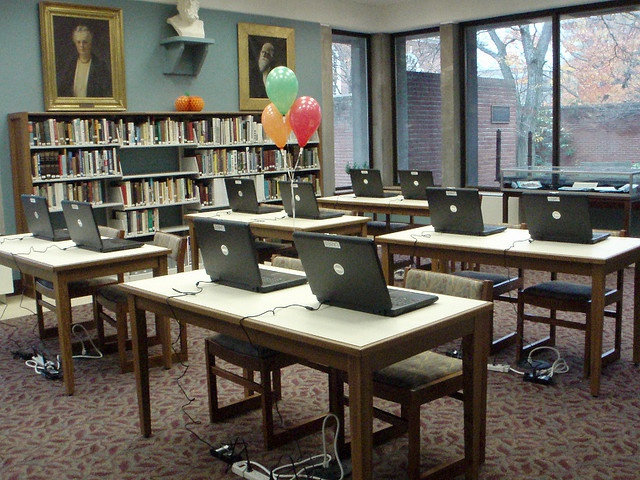Describe the objects in this image and their specific colors. I can see dining table in gray, black, beige, and maroon tones, book in gray, black, darkgray, and tan tones, chair in gray, black, and darkgray tones, chair in gray and black tones, and laptop in gray, black, darkgreen, and darkgray tones in this image. 